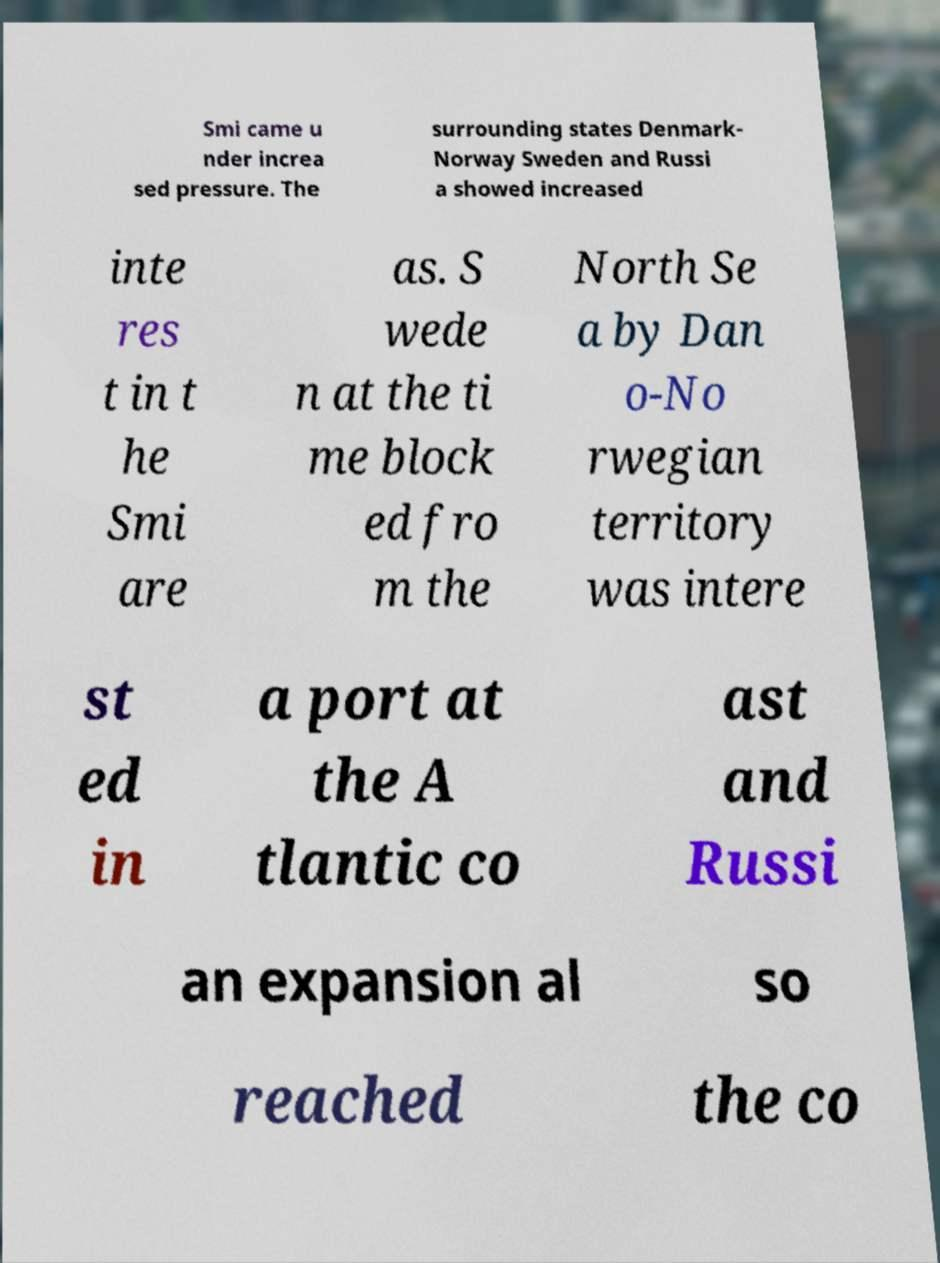I need the written content from this picture converted into text. Can you do that? Smi came u nder increa sed pressure. The surrounding states Denmark- Norway Sweden and Russi a showed increased inte res t in t he Smi are as. S wede n at the ti me block ed fro m the North Se a by Dan o-No rwegian territory was intere st ed in a port at the A tlantic co ast and Russi an expansion al so reached the co 